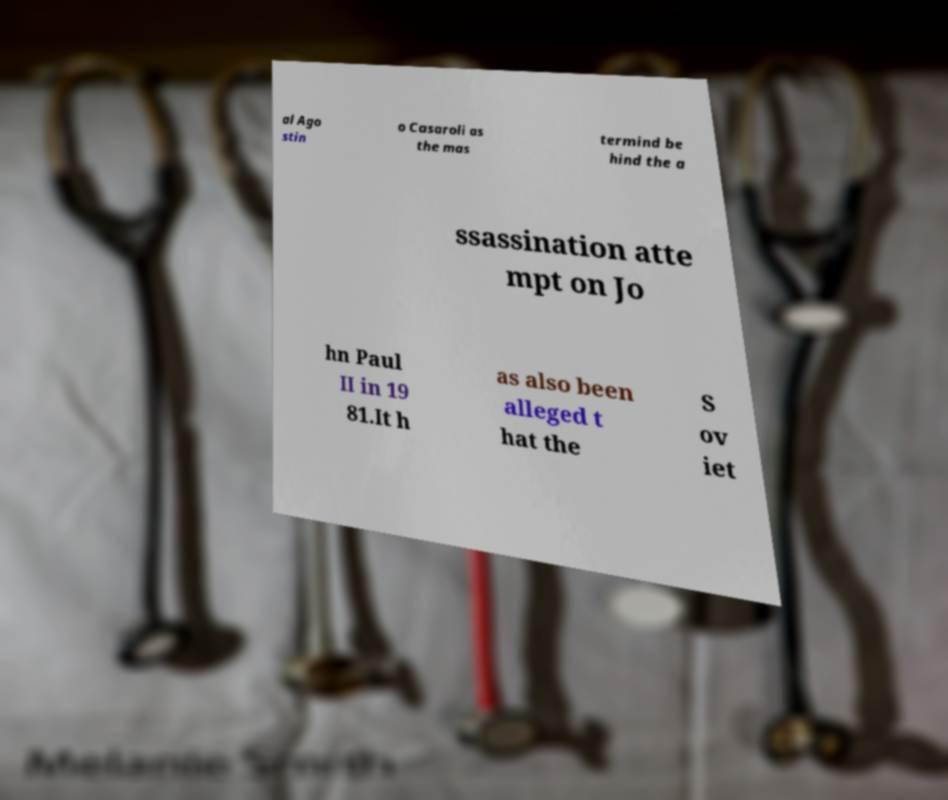Could you assist in decoding the text presented in this image and type it out clearly? al Ago stin o Casaroli as the mas termind be hind the a ssassination atte mpt on Jo hn Paul II in 19 81.It h as also been alleged t hat the S ov iet 